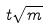Convert formula to latex. <formula><loc_0><loc_0><loc_500><loc_500>t \sqrt { m }</formula> 